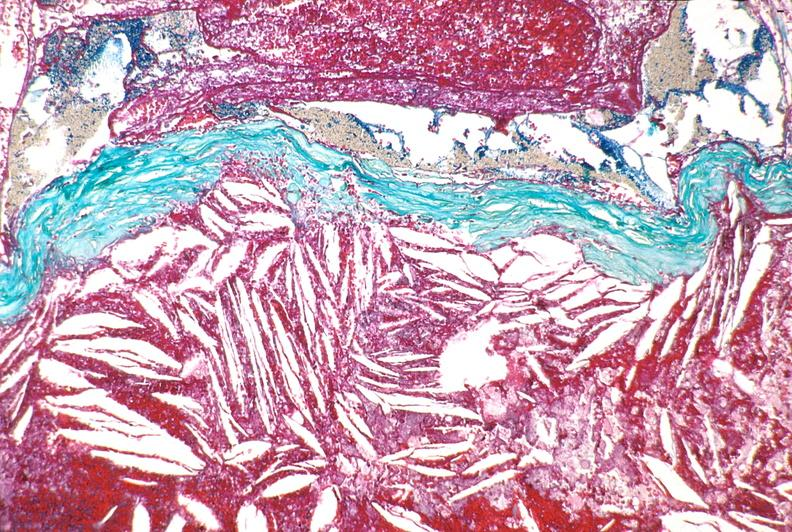does natural color show right coronary artery, atherosclerosis and acute thrombus?
Answer the question using a single word or phrase. No 